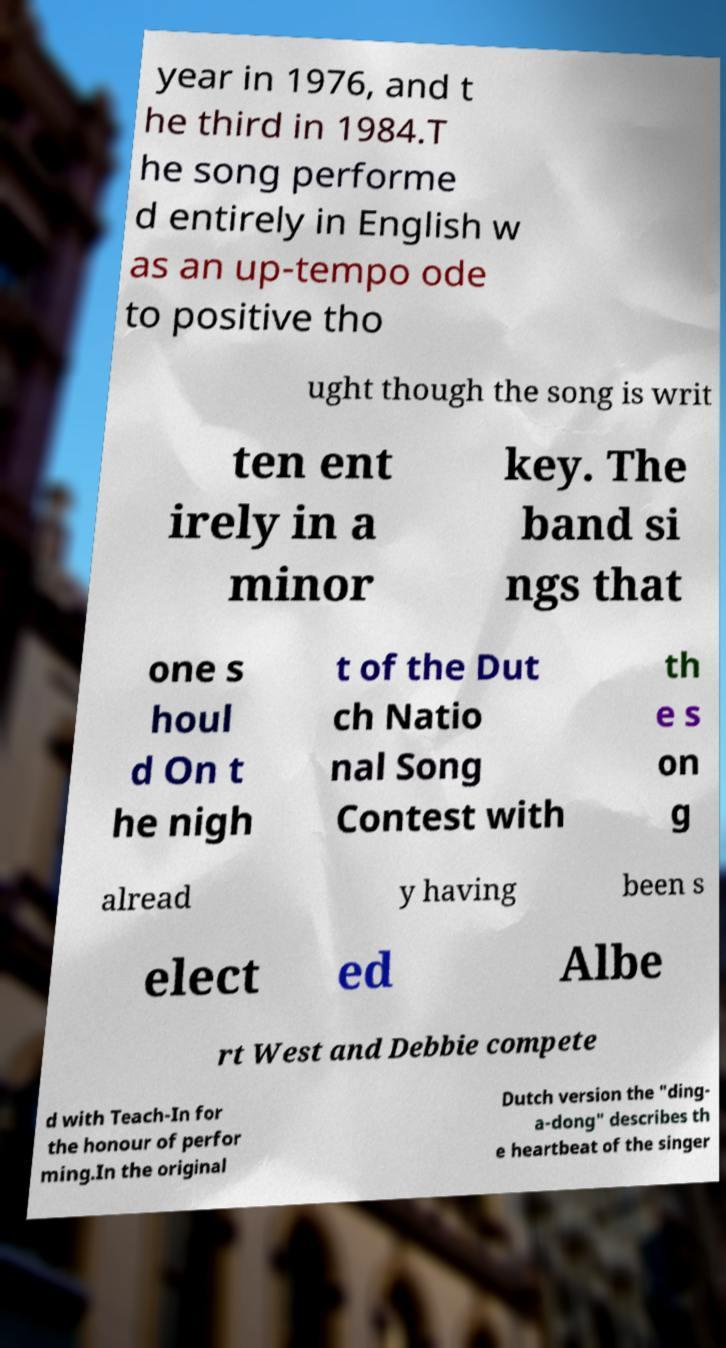Please identify and transcribe the text found in this image. year in 1976, and t he third in 1984.T he song performe d entirely in English w as an up-tempo ode to positive tho ught though the song is writ ten ent irely in a minor key. The band si ngs that one s houl d On t he nigh t of the Dut ch Natio nal Song Contest with th e s on g alread y having been s elect ed Albe rt West and Debbie compete d with Teach-In for the honour of perfor ming.In the original Dutch version the "ding- a-dong" describes th e heartbeat of the singer 